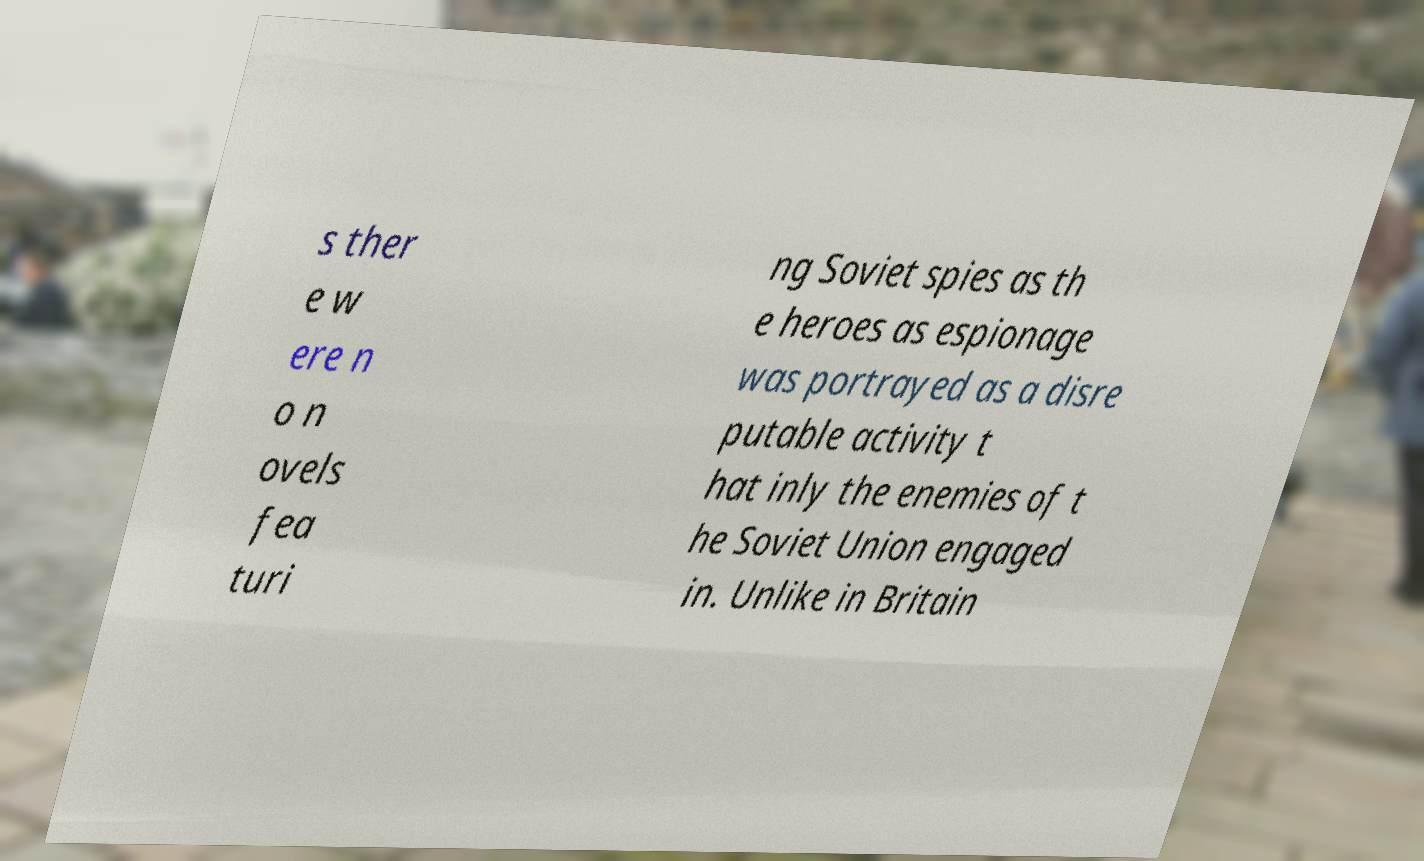Please identify and transcribe the text found in this image. s ther e w ere n o n ovels fea turi ng Soviet spies as th e heroes as espionage was portrayed as a disre putable activity t hat inly the enemies of t he Soviet Union engaged in. Unlike in Britain 